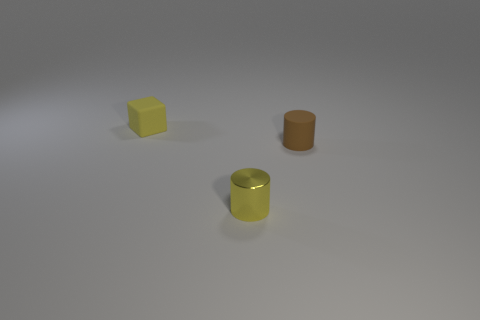Add 1 small yellow cubes. How many objects exist? 4 Subtract all cylinders. How many objects are left? 1 Add 2 yellow rubber cubes. How many yellow rubber cubes are left? 3 Add 1 small rubber objects. How many small rubber objects exist? 3 Subtract 0 yellow balls. How many objects are left? 3 Subtract all tiny cylinders. Subtract all tiny cyan rubber objects. How many objects are left? 1 